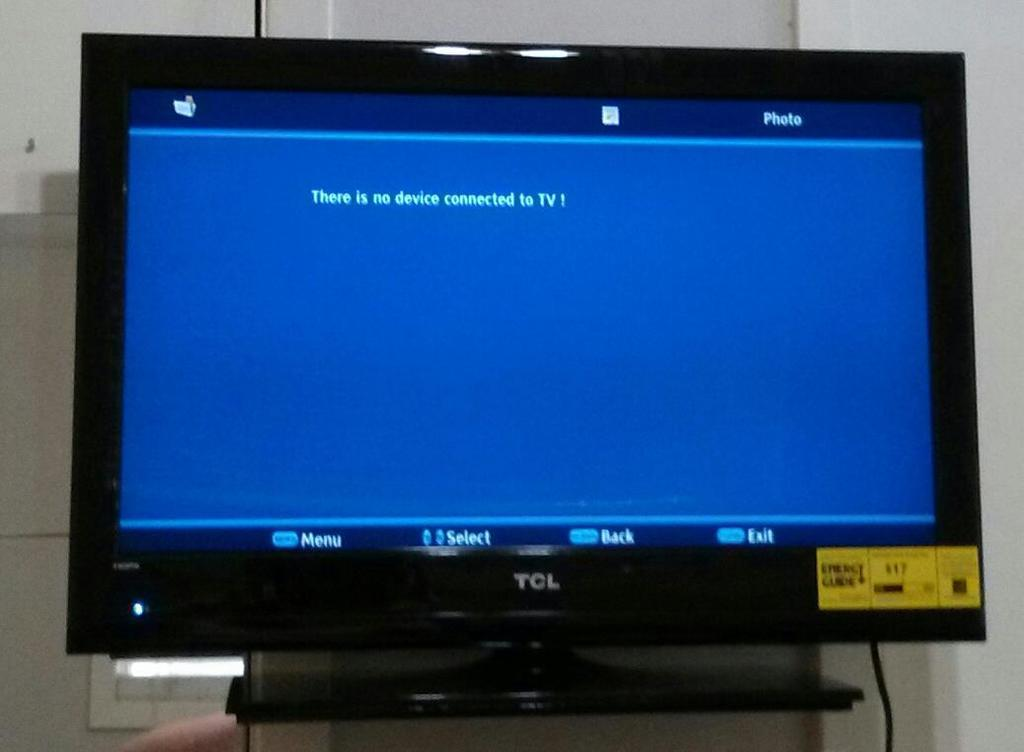<image>
Write a terse but informative summary of the picture. A TCL television displays a message that says, "There is no device connected to TV!" 